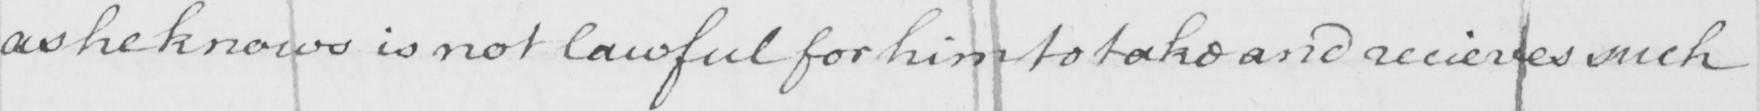What text is written in this handwritten line? as he knows is not lawful for him to take and receives such 